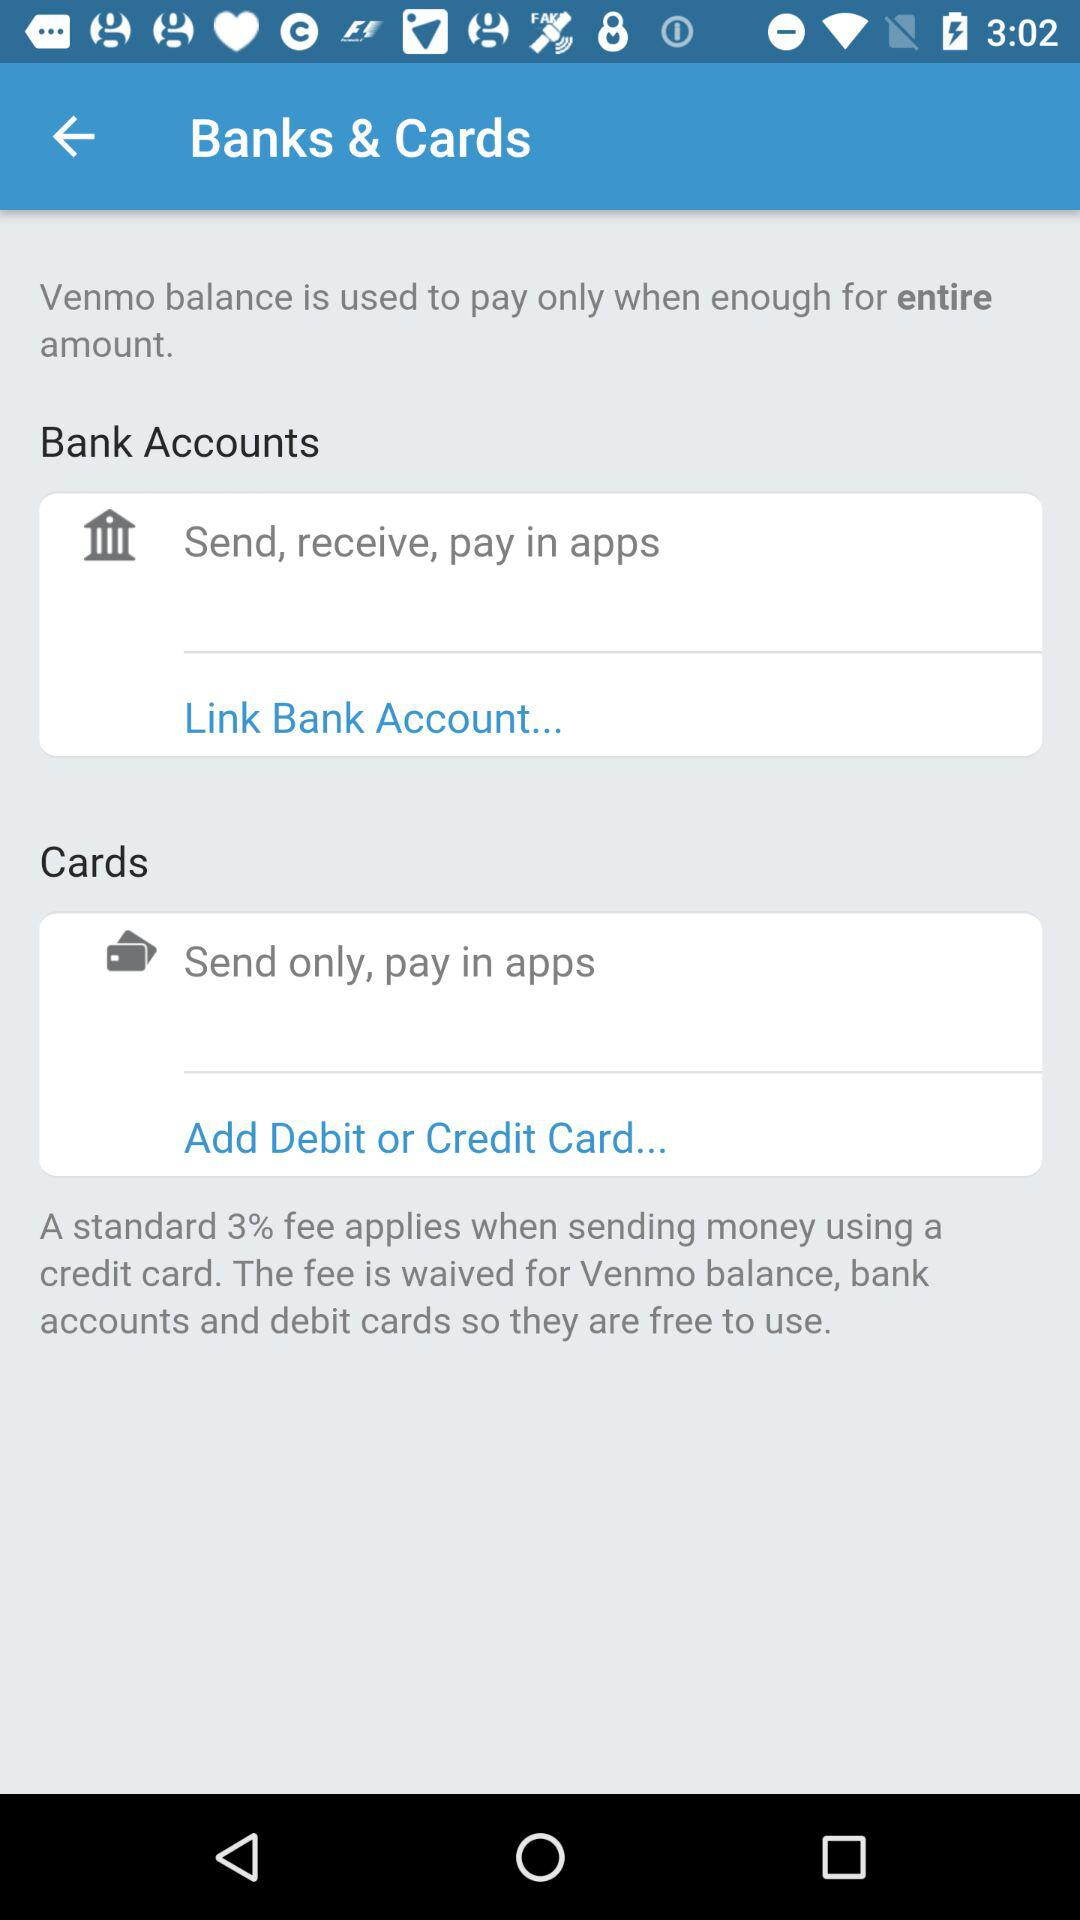How much is the fee for sending money using a credit card?
Answer the question using a single word or phrase. 3% 